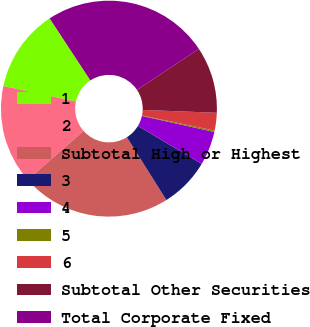Convert chart to OTSL. <chart><loc_0><loc_0><loc_500><loc_500><pie_chart><fcel>1<fcel>2<fcel>Subtotal High or Highest<fcel>3<fcel>4<fcel>5<fcel>6<fcel>Subtotal Other Securities<fcel>Total Corporate Fixed<nl><fcel>12.39%<fcel>14.82%<fcel>22.47%<fcel>7.52%<fcel>5.08%<fcel>0.21%<fcel>2.65%<fcel>9.95%<fcel>24.91%<nl></chart> 